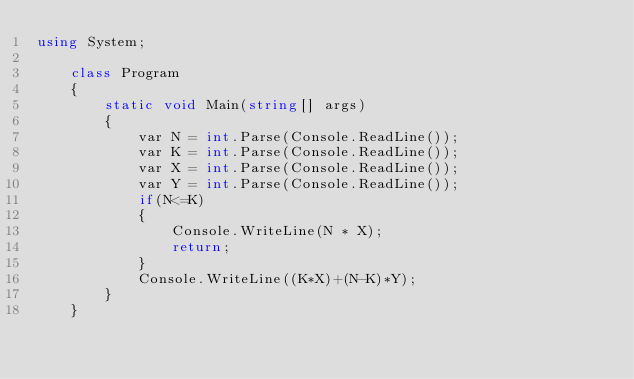Convert code to text. <code><loc_0><loc_0><loc_500><loc_500><_C#_>using System;

    class Program
    {
        static void Main(string[] args)
        {
            var N = int.Parse(Console.ReadLine());
            var K = int.Parse(Console.ReadLine());
            var X = int.Parse(Console.ReadLine());
            var Y = int.Parse(Console.ReadLine());
            if(N<=K)
            {
                Console.WriteLine(N * X);
                return;
            }
            Console.WriteLine((K*X)+(N-K)*Y);
        }
    }</code> 